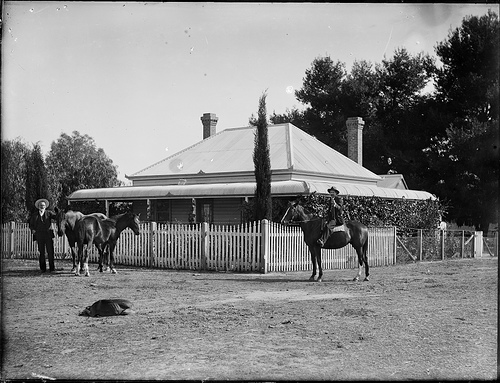Can you describe the setting of the image? The image features a tranquil, pastoral scene with a characteristic single-story house, complete with a veranda and a neat, white picket fence. Lush trees can be seen in the background which, along with the open gate, suggests the inviting nature of this homestead. What era does this photo look like it's from? The style of the architecture, the attire of the individuals, and the monochrome quality suggest this picture was likely taken in the late 19th or early 20th century. Such historical photographs provide a window into life at the time. 